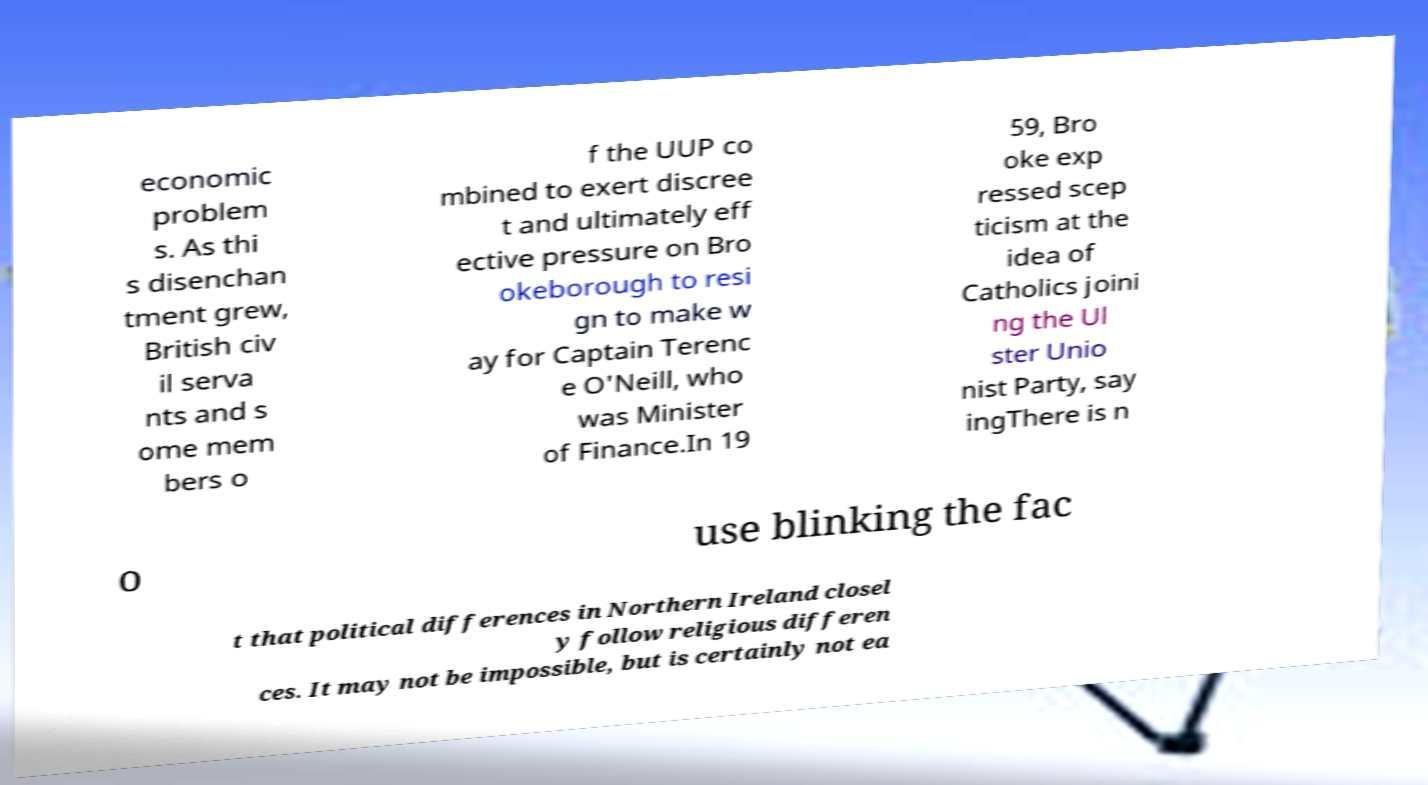I need the written content from this picture converted into text. Can you do that? economic problem s. As thi s disenchan tment grew, British civ il serva nts and s ome mem bers o f the UUP co mbined to exert discree t and ultimately eff ective pressure on Bro okeborough to resi gn to make w ay for Captain Terenc e O'Neill, who was Minister of Finance.In 19 59, Bro oke exp ressed scep ticism at the idea of Catholics joini ng the Ul ster Unio nist Party, say ingThere is n o use blinking the fac t that political differences in Northern Ireland closel y follow religious differen ces. It may not be impossible, but is certainly not ea 